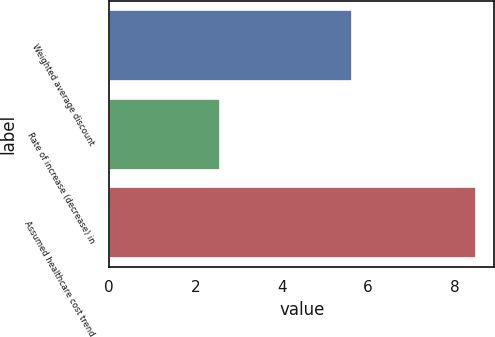<chart> <loc_0><loc_0><loc_500><loc_500><bar_chart><fcel>Weighted average discount<fcel>Rate of increase (decrease) in<fcel>Assumed healthcare cost trend<nl><fcel>5.63<fcel>2.57<fcel>8.5<nl></chart> 